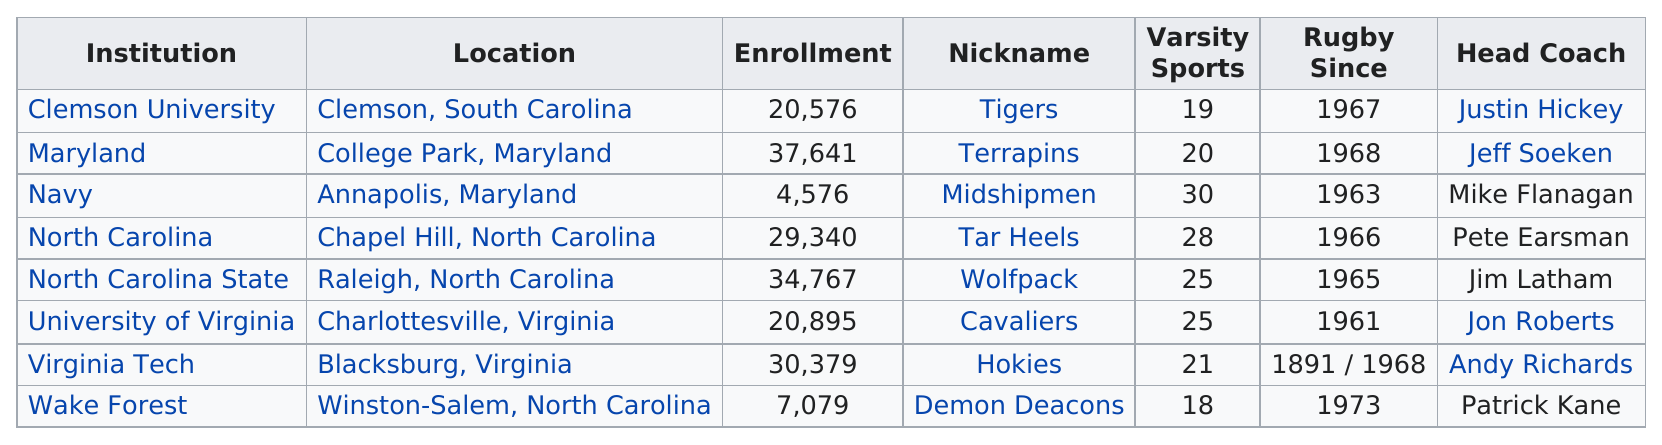Give some essential details in this illustration. The North Carolina Wolfpack has been in existence for one year longer than the Tar Heels. North Carolina State University, also known as NC State, is commonly referred to as the "Wolfpack. The head coach, Jon Roberts, led his team from Charlottesville, Virginia. There are three institutes from North Carolina in the Association of College and Research Libraries (ACRL). Institutions with an even enrollment are listed as follows: 3.. 